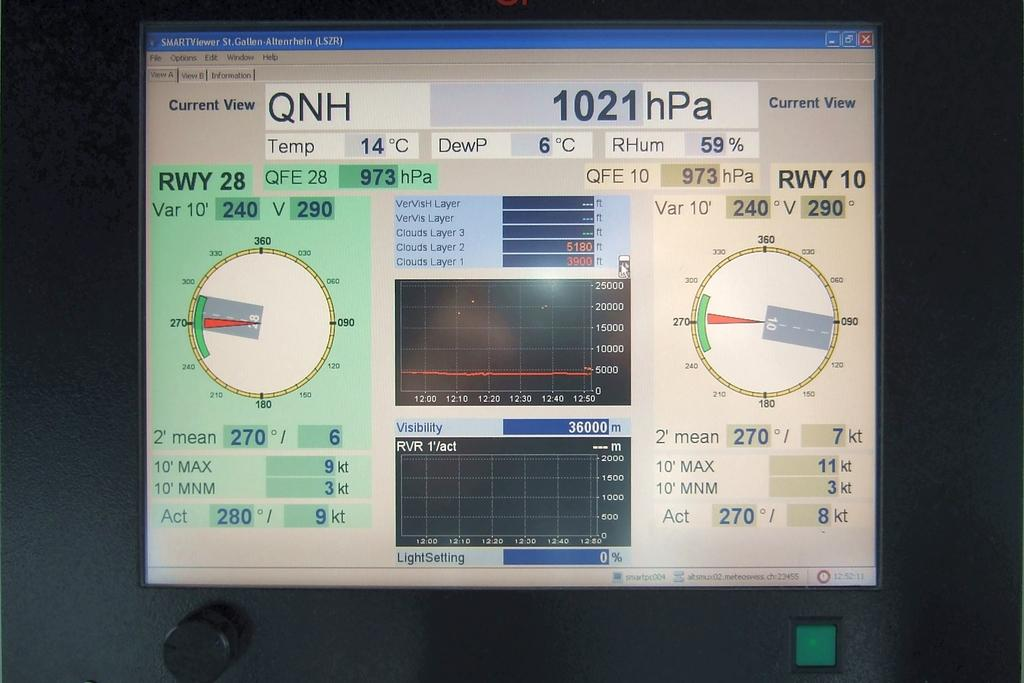<image>
Present a compact description of the photo's key features. A machine monitor with QNH 1021hPa RWY 28 is checking vitals or airplane variations. 